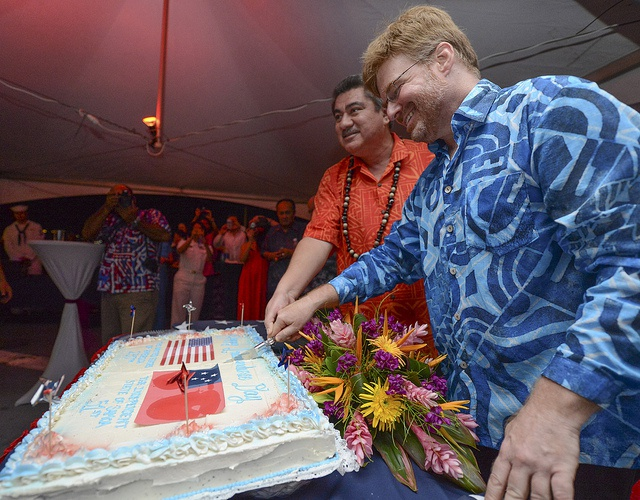Describe the objects in this image and their specific colors. I can see people in brown, navy, darkblue, gray, and blue tones, cake in brown, lightgray, darkgray, lightblue, and lightpink tones, people in brown, maroon, and black tones, people in brown, black, maroon, gray, and navy tones, and people in brown, black, maroon, and olive tones in this image. 